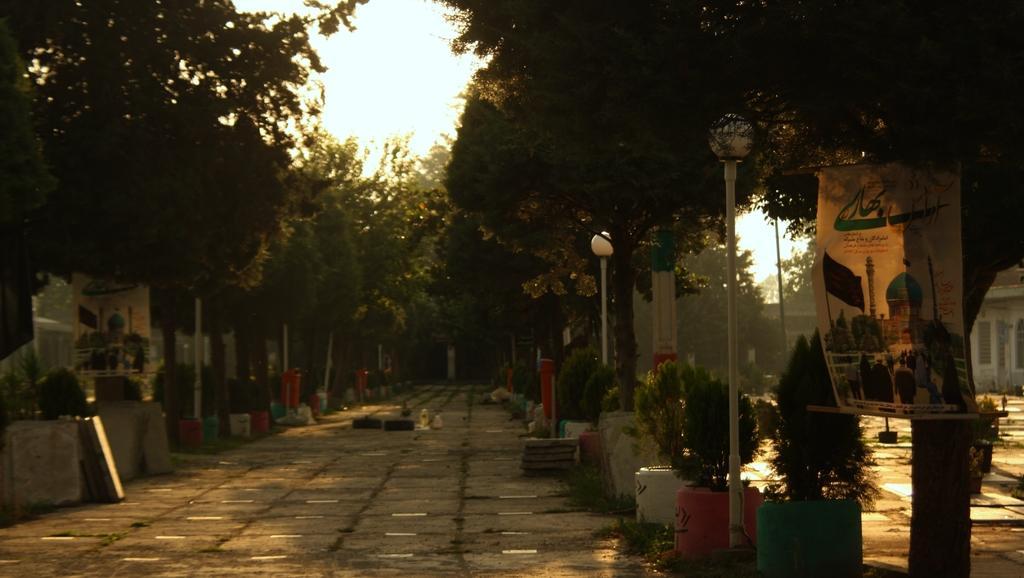Describe this image in one or two sentences. In this image I can see there are trees on either side, on the right side there is a banner on this tree. At the top it is the sky. 